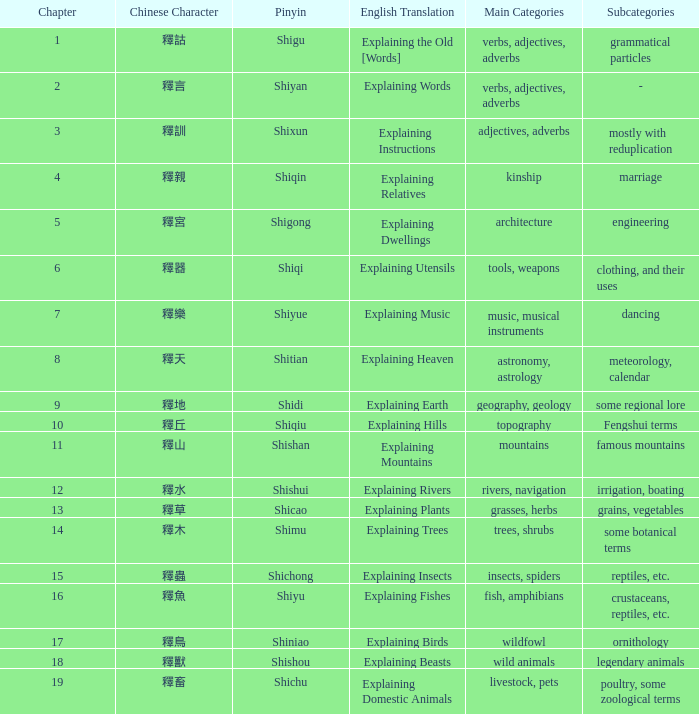Name the chapter with chinese of 釋水 12.0. 